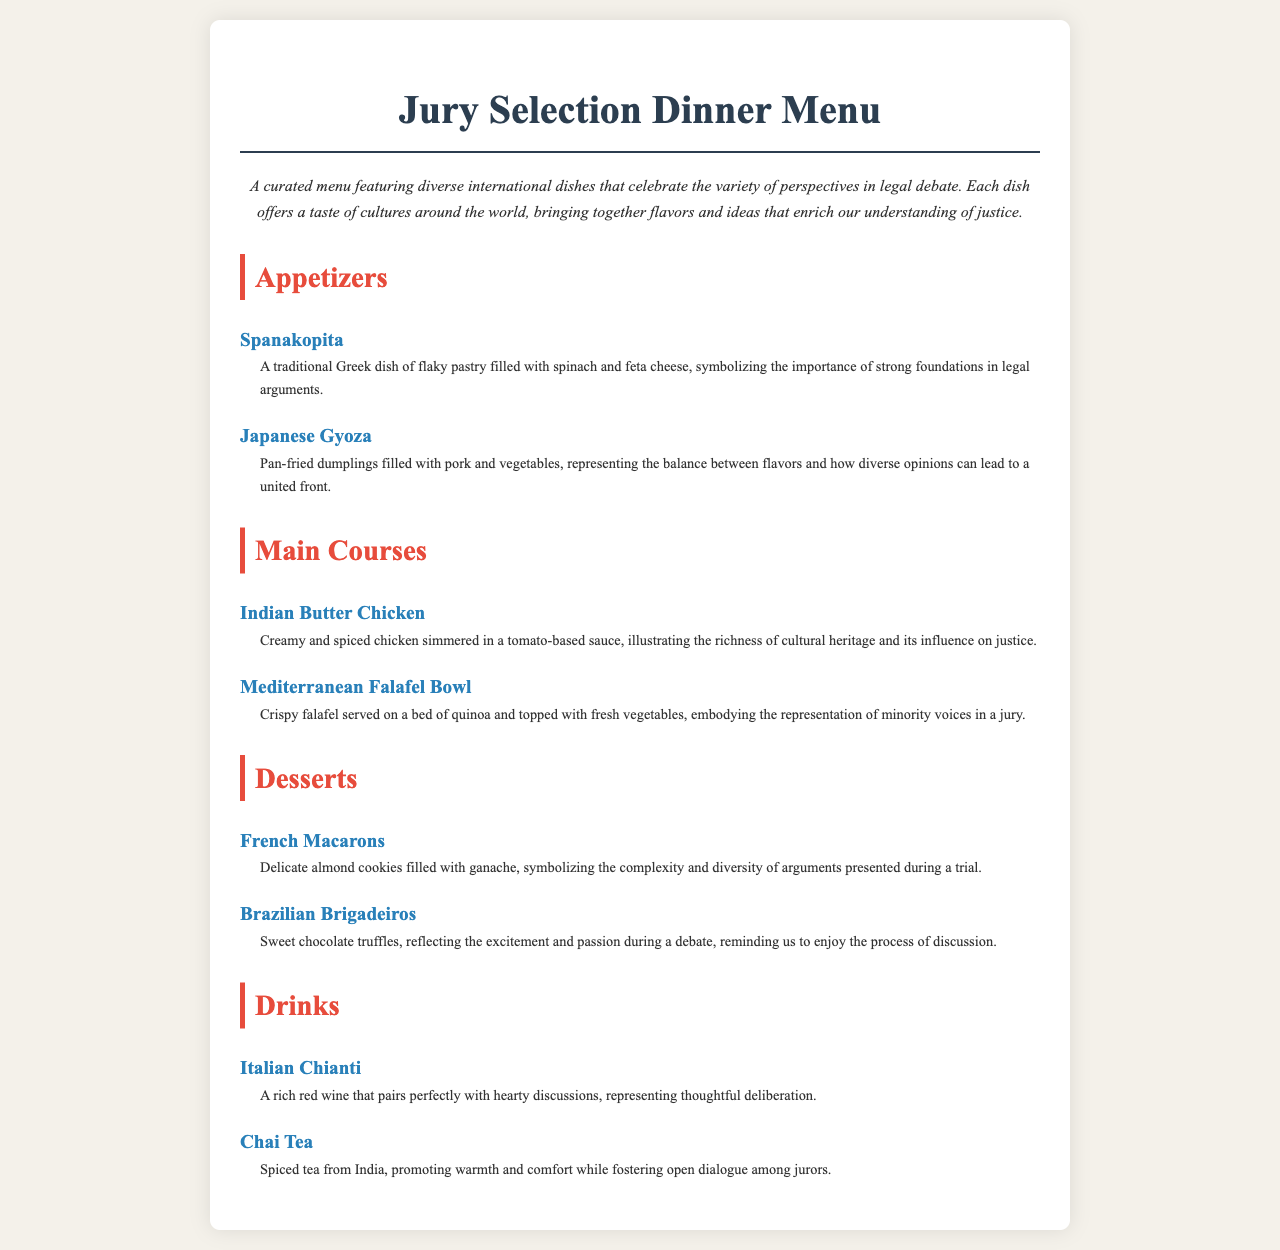What is the title of the menu? The title of the menu is prominently displayed at the top of the document.
Answer: Jury Selection Dinner Menu What type of dish is Spanakopita? The type of dish is categorized under appetizers, as listed in the document.
Answer: Appetizer What main course illustrates the richness of cultural heritage? This dish is specifically described in the main courses section of the menu.
Answer: Indian Butter Chicken How many desserts are listed in the menu? The menu contains two desserts, which can be counted in the desserts section.
Answer: 2 What drink pairs perfectly with hearty discussions? This drink is mentioned under the drinks section of the menu.
Answer: Italian Chianti What does the Mediterranean Falafel Bowl represent? The representation is clearly stated in the description of the dish under main courses.
Answer: Minority voices in a jury What symbol does French Macarons represent? This symbol is explicitly explained in the dessert's description.
Answer: Complexity and diversity of arguments 